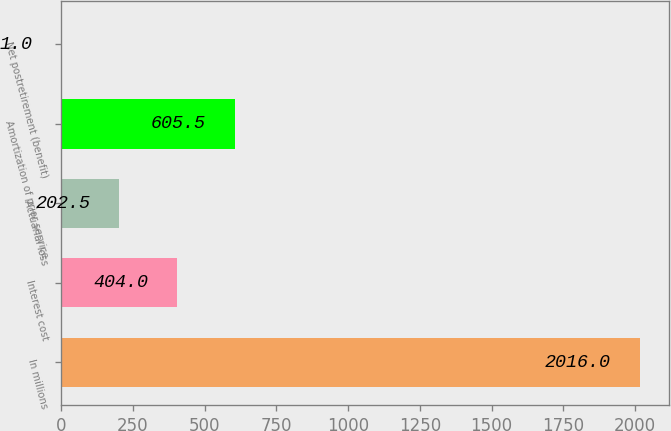Convert chart. <chart><loc_0><loc_0><loc_500><loc_500><bar_chart><fcel>In millions<fcel>Interest cost<fcel>Actuarial loss<fcel>Amortization of prior service<fcel>Net postretirement (benefit)<nl><fcel>2016<fcel>404<fcel>202.5<fcel>605.5<fcel>1<nl></chart> 